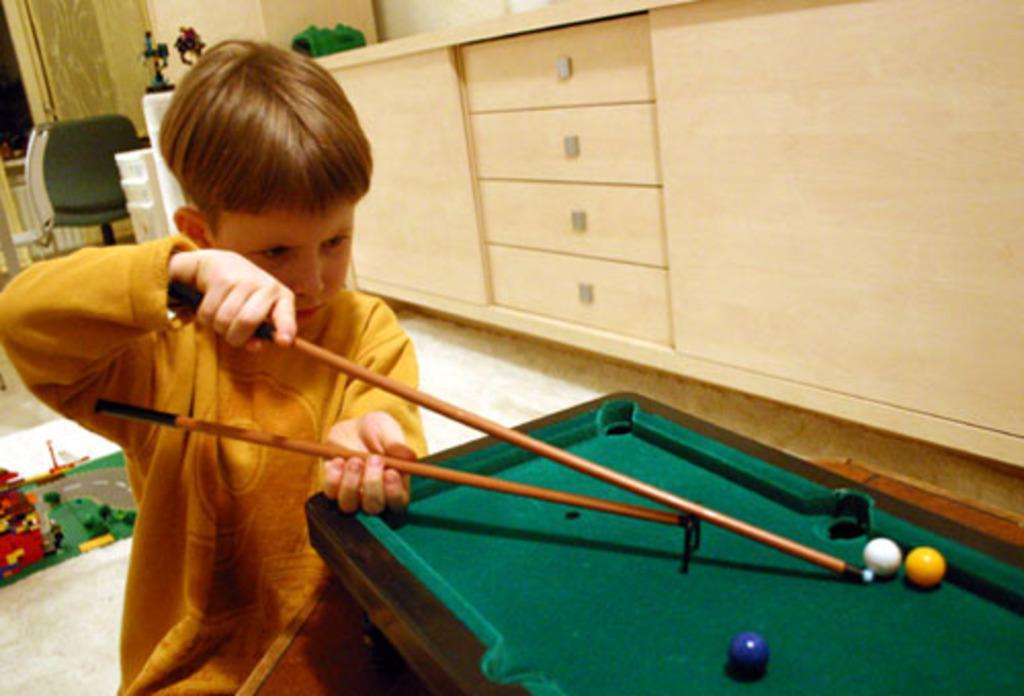Describe this image in one or two sentences. In the image we can see there is a kid who is standing and he is wearing yellow colour shirt and he is holding sticks. There is a small billiard board on which there are balls kept on it. Behind there is a chair which is in green colour and table there are toys. 